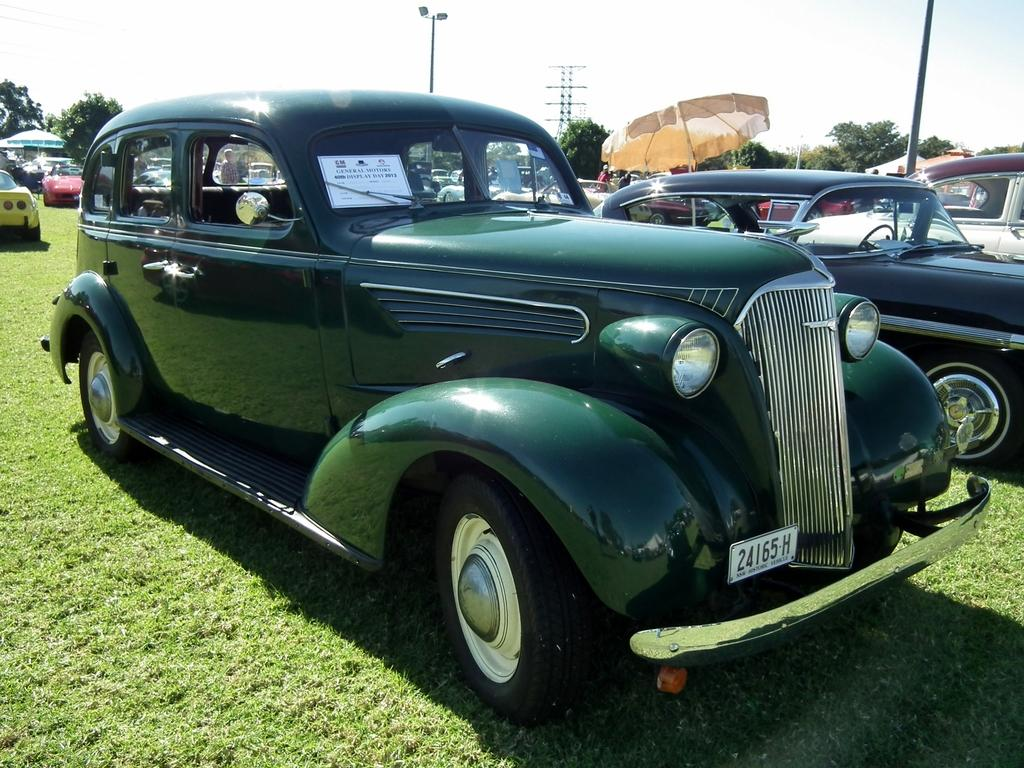What type of vegetation is present on the ground in the image? There is grass on the ground in the image. What type of vehicles can be seen in the image? There are cars in the image. What type of temporary shelters are present in the image? There are tents in the image. What type of structures can be seen in the image? There are poles in the image. What type of living organisms are present in the image? There are people in the image. What type of trees are present in the image? There are green trees in the image. What is visible in the background of the image? The sky is visible in the background of the image. What type of smell can be detected from the image? There is no information about smells in the image, so it cannot be determined from the image. What type of society is depicted in the image? There is no information about society in the image, so it cannot be determined from the image. 